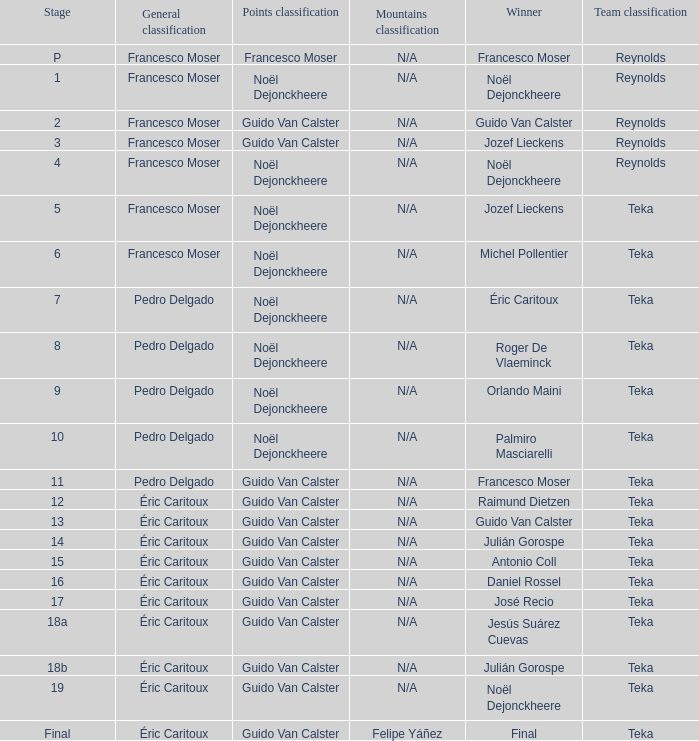Name the points classification of stage 16 Guido Van Calster. 